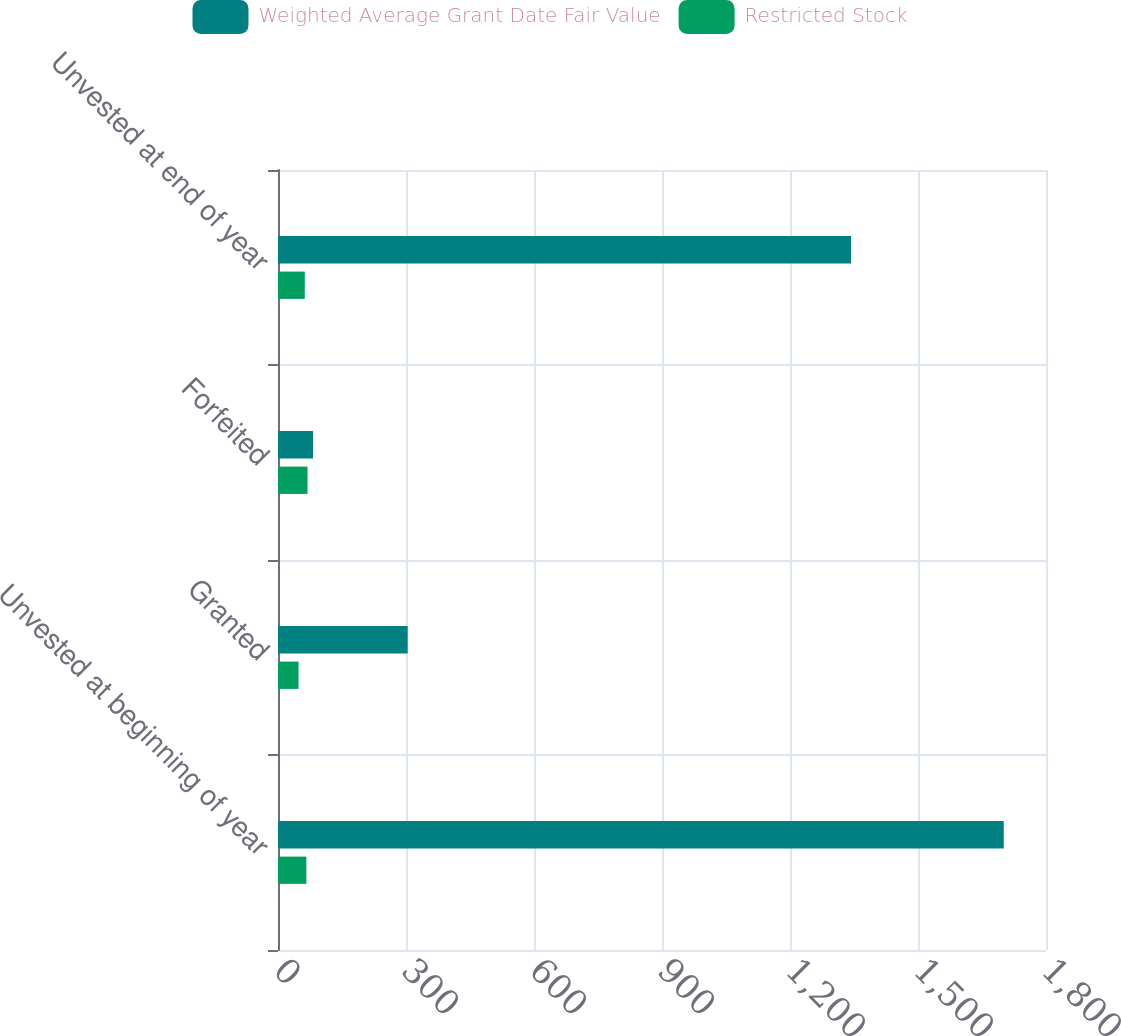<chart> <loc_0><loc_0><loc_500><loc_500><stacked_bar_chart><ecel><fcel>Unvested at beginning of year<fcel>Granted<fcel>Forfeited<fcel>Unvested at end of year<nl><fcel>Weighted Average Grant Date Fair Value<fcel>1701<fcel>304<fcel>82<fcel>1343<nl><fcel>Restricted Stock<fcel>66.49<fcel>48.14<fcel>69.23<fcel>62.75<nl></chart> 